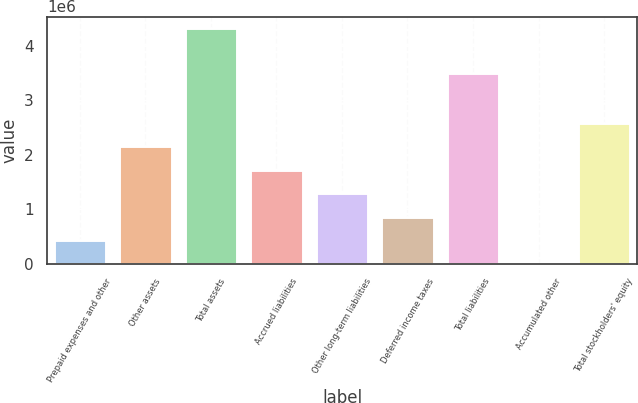Convert chart to OTSL. <chart><loc_0><loc_0><loc_500><loc_500><bar_chart><fcel>Prepaid expenses and other<fcel>Other assets<fcel>Total assets<fcel>Accrued liabilities<fcel>Other long-term liabilities<fcel>Deferred income taxes<fcel>Total liabilities<fcel>Accumulated other<fcel>Total stockholders' equity<nl><fcel>431586<fcel>2.15706e+06<fcel>4.31391e+06<fcel>1.72569e+06<fcel>1.29433e+06<fcel>862956<fcel>3.49252e+06<fcel>217<fcel>2.58843e+06<nl></chart> 